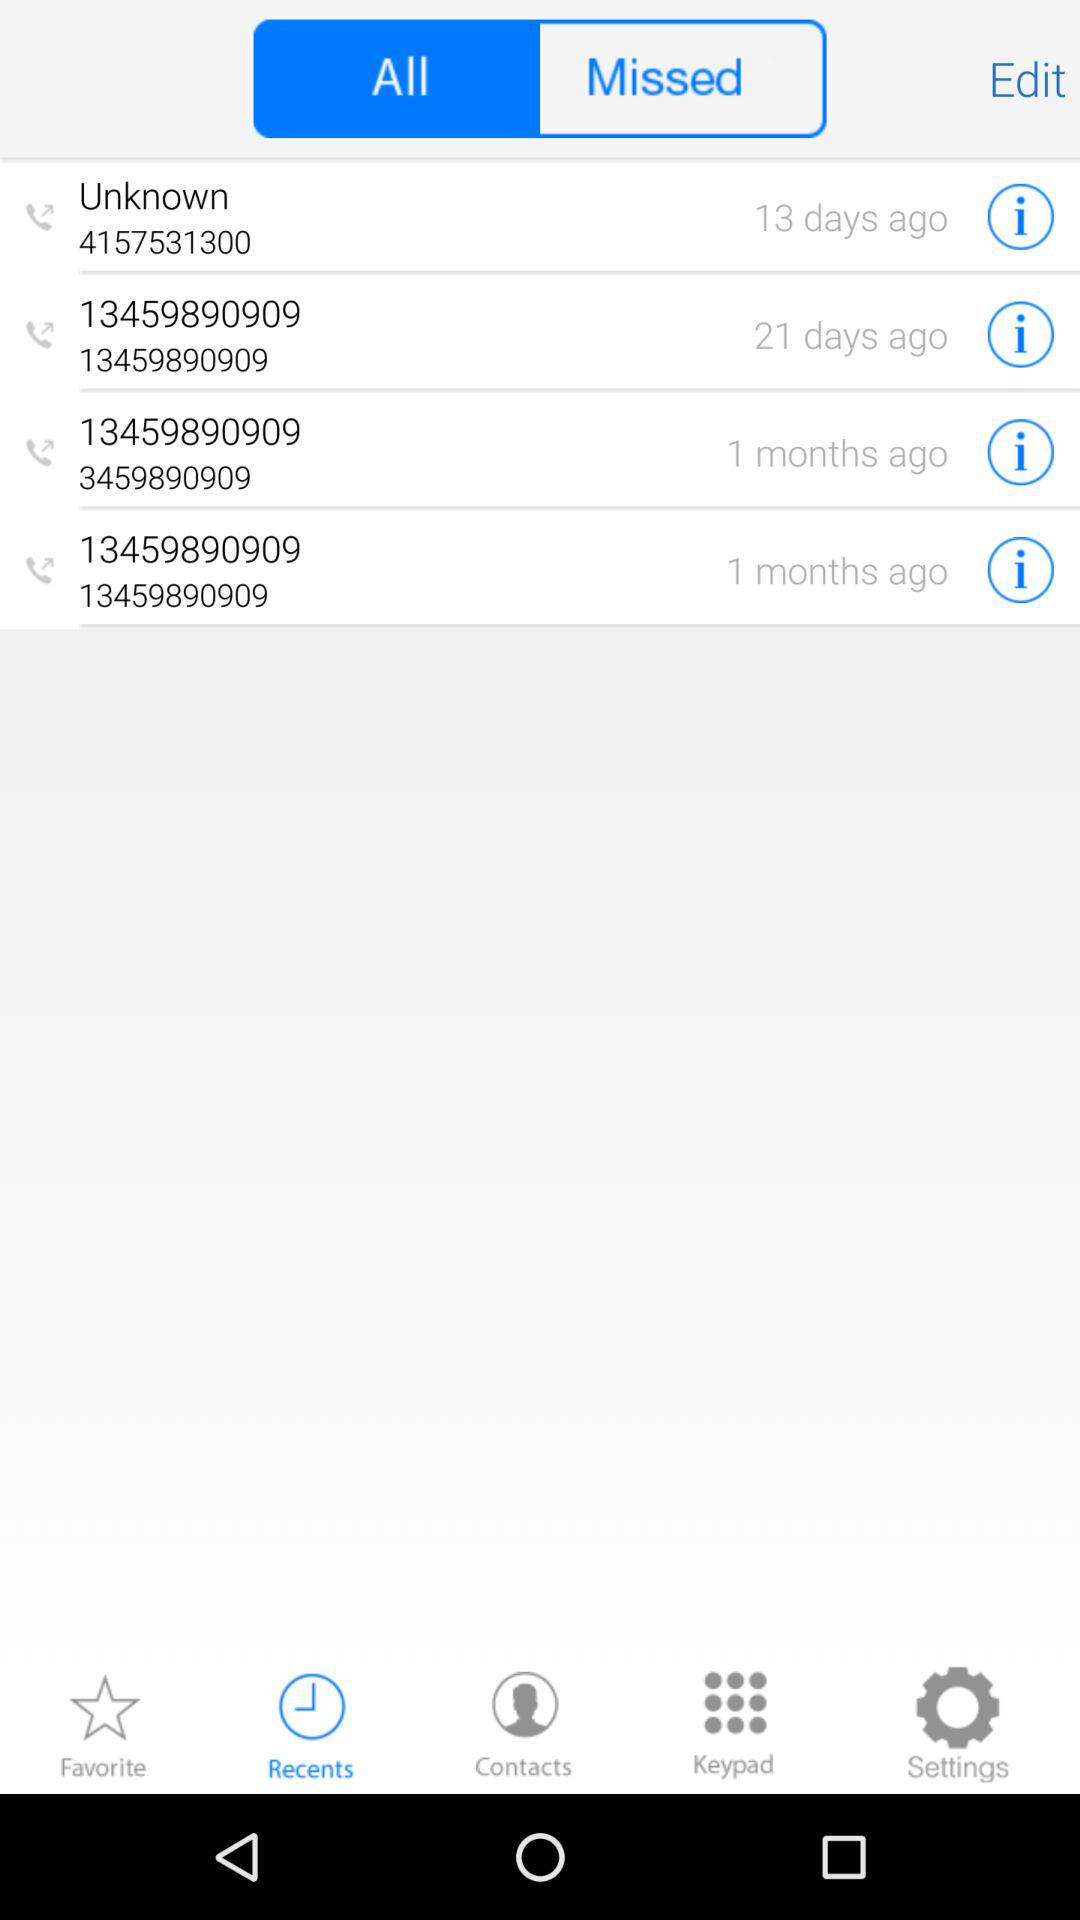What number is saved as "Unknown"? The number 4157531300 is saved as "Unknown". 